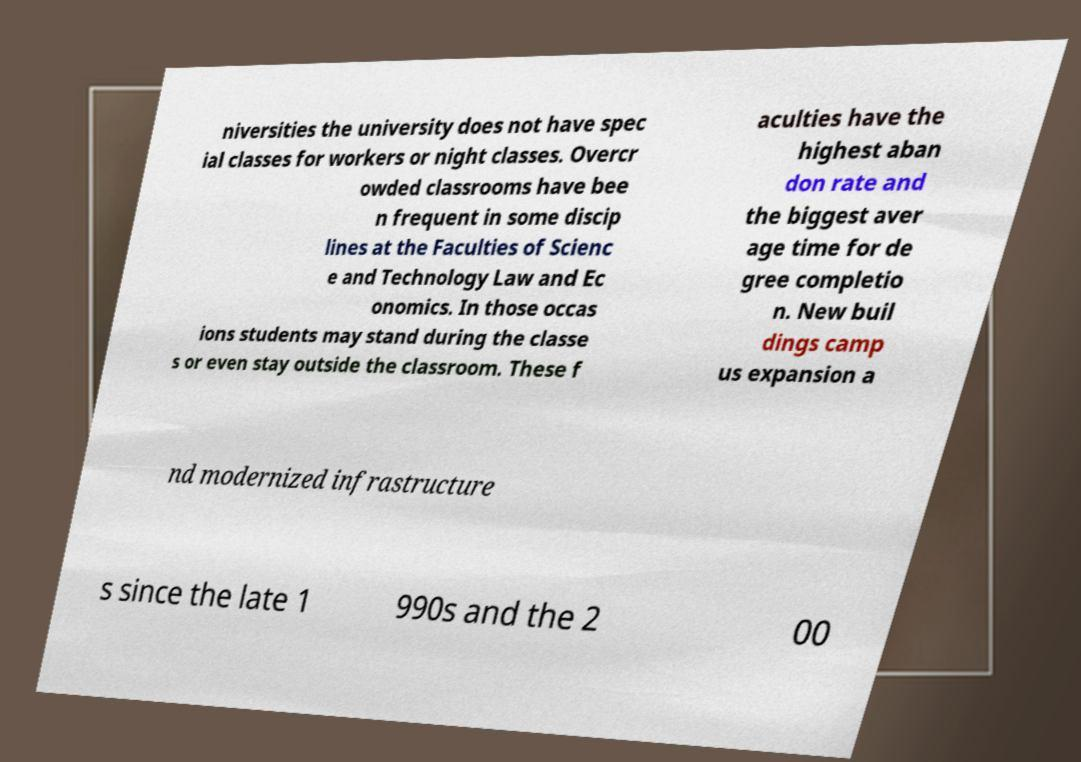Could you assist in decoding the text presented in this image and type it out clearly? niversities the university does not have spec ial classes for workers or night classes. Overcr owded classrooms have bee n frequent in some discip lines at the Faculties of Scienc e and Technology Law and Ec onomics. In those occas ions students may stand during the classe s or even stay outside the classroom. These f aculties have the highest aban don rate and the biggest aver age time for de gree completio n. New buil dings camp us expansion a nd modernized infrastructure s since the late 1 990s and the 2 00 